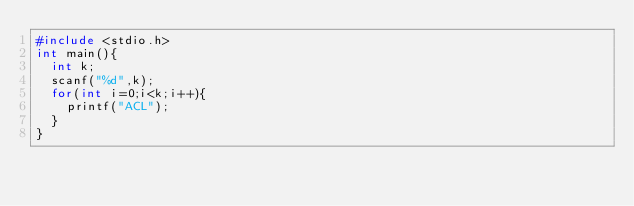Convert code to text. <code><loc_0><loc_0><loc_500><loc_500><_C_>#include <stdio.h>
int main(){
  int k;
  scanf("%d",k);
  for(int i=0;i<k;i++){
    printf("ACL");
  }
}</code> 